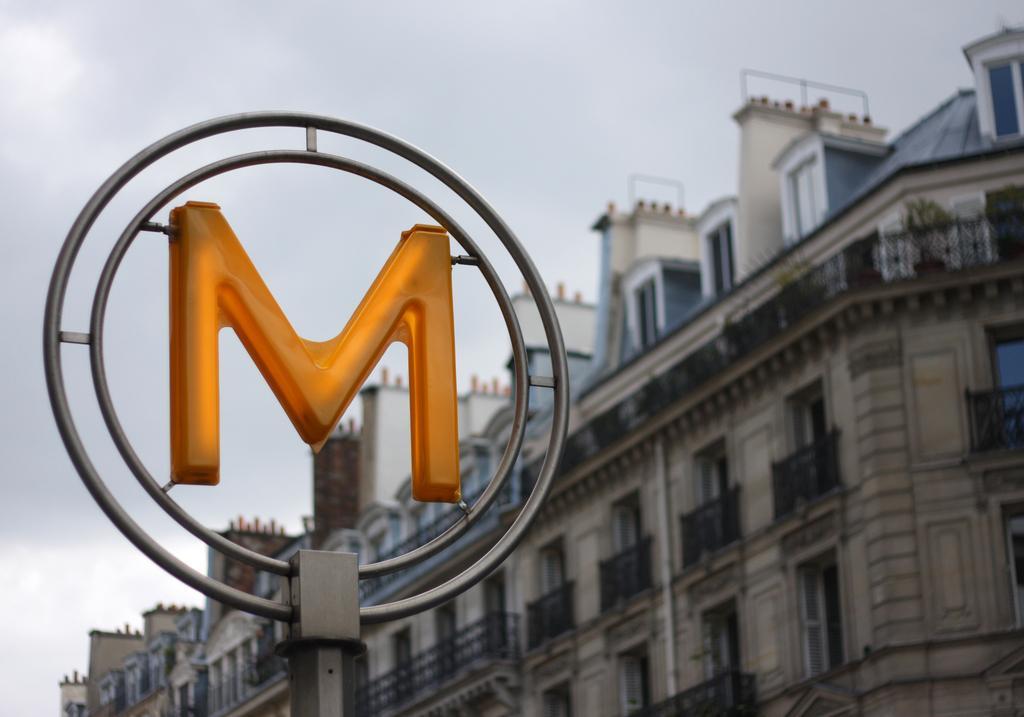Please provide a concise description of this image. In this picture I can observe an alphabet in the two rings. This alphabet is in yellow color. In the background there is a building and sky. 